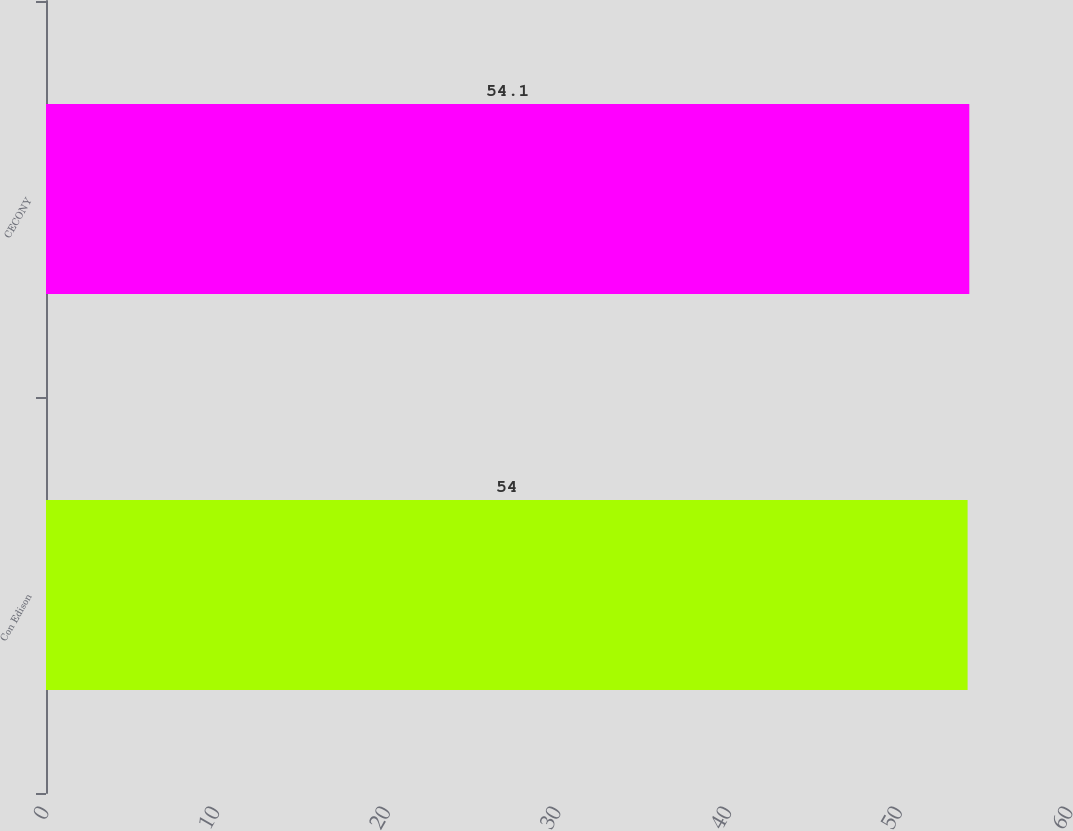Convert chart. <chart><loc_0><loc_0><loc_500><loc_500><bar_chart><fcel>Con Edison<fcel>CECONY<nl><fcel>54<fcel>54.1<nl></chart> 